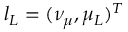<formula> <loc_0><loc_0><loc_500><loc_500>l _ { L } = ( \nu _ { \mu } , \mu _ { L } ) ^ { T }</formula> 